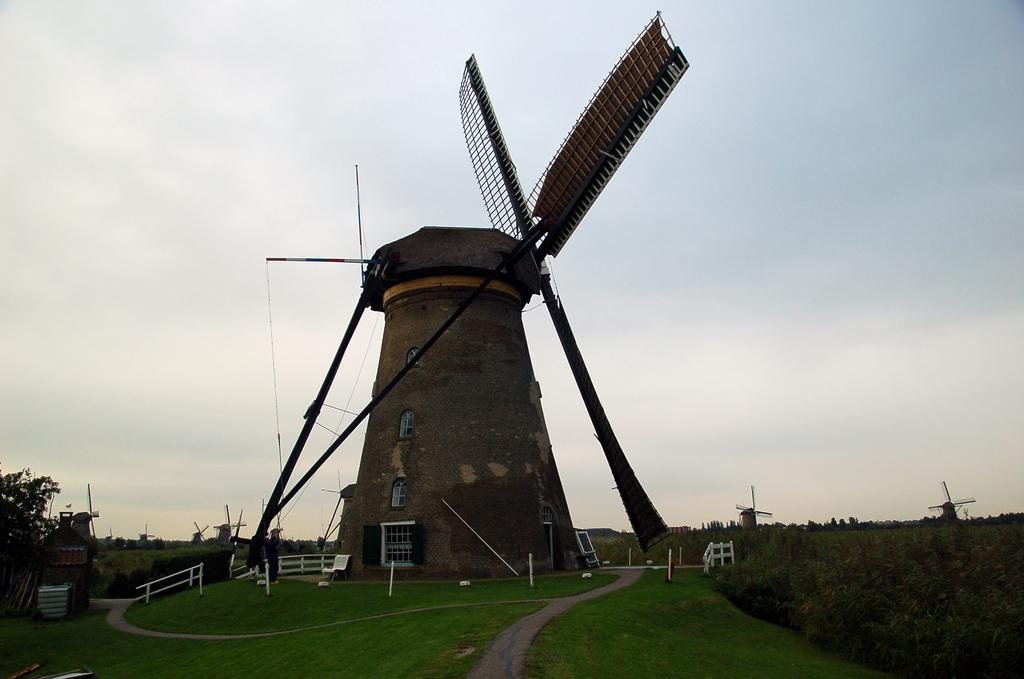What type of structures can be seen in the image? There are windmills and a tower in the image. What are the rods used for in the image? The purpose of the rods is not specified in the image. What type of vegetation is present in the image? There are plants, trees, and grass in the image. What is visible in the background of the image? The sky is visible in the background of the image. What type of toys can be seen floating on the boat in the image? There is no boat or toys present in the image. What kind of stamp is visible on the tower in the image? There is no stamp visible on the tower in the image. 